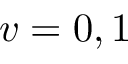Convert formula to latex. <formula><loc_0><loc_0><loc_500><loc_500>v = 0 , 1</formula> 